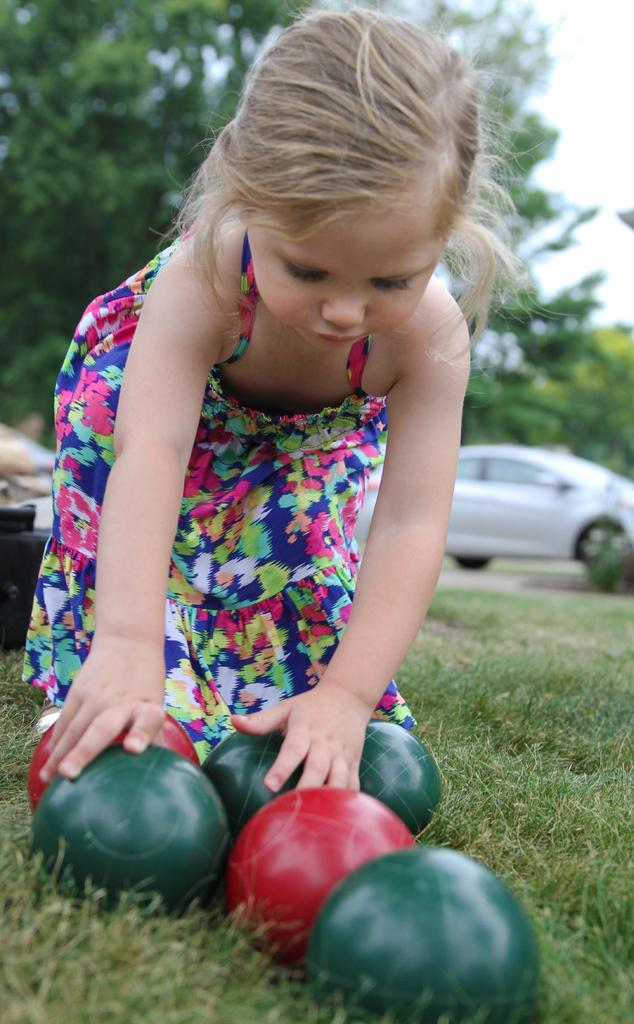Who is the main subject in the image? There is a girl in the image. What is the girl doing in the image? The girl is playing with balls. Where is the girl located in the image? The girl is on the grass. What can be seen behind the girl in the image? There is a car behind the girl. What type of vegetation is visible around the car? There are trees around the car. What type of crayon is the girl using to draw on the grass? There is no crayon present in the image; the girl is playing with balls. 